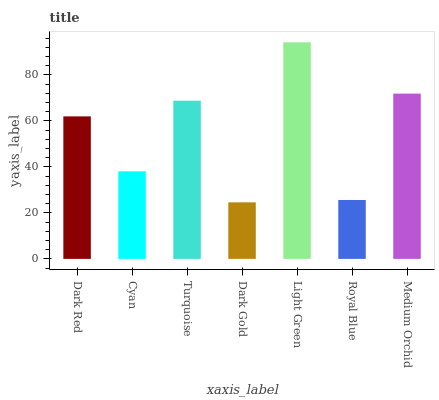Is Dark Gold the minimum?
Answer yes or no. Yes. Is Light Green the maximum?
Answer yes or no. Yes. Is Cyan the minimum?
Answer yes or no. No. Is Cyan the maximum?
Answer yes or no. No. Is Dark Red greater than Cyan?
Answer yes or no. Yes. Is Cyan less than Dark Red?
Answer yes or no. Yes. Is Cyan greater than Dark Red?
Answer yes or no. No. Is Dark Red less than Cyan?
Answer yes or no. No. Is Dark Red the high median?
Answer yes or no. Yes. Is Dark Red the low median?
Answer yes or no. Yes. Is Medium Orchid the high median?
Answer yes or no. No. Is Light Green the low median?
Answer yes or no. No. 